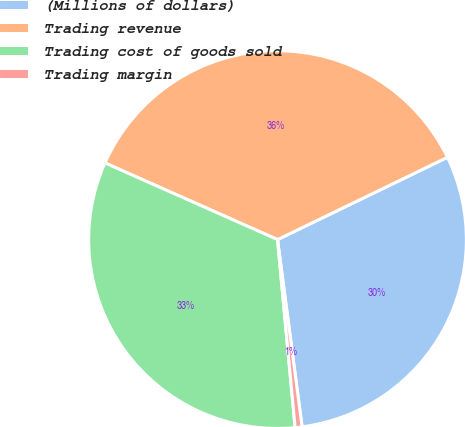Convert chart. <chart><loc_0><loc_0><loc_500><loc_500><pie_chart><fcel>(Millions of dollars)<fcel>Trading revenue<fcel>Trading cost of goods sold<fcel>Trading margin<nl><fcel>30.1%<fcel>36.17%<fcel>33.14%<fcel>0.59%<nl></chart> 